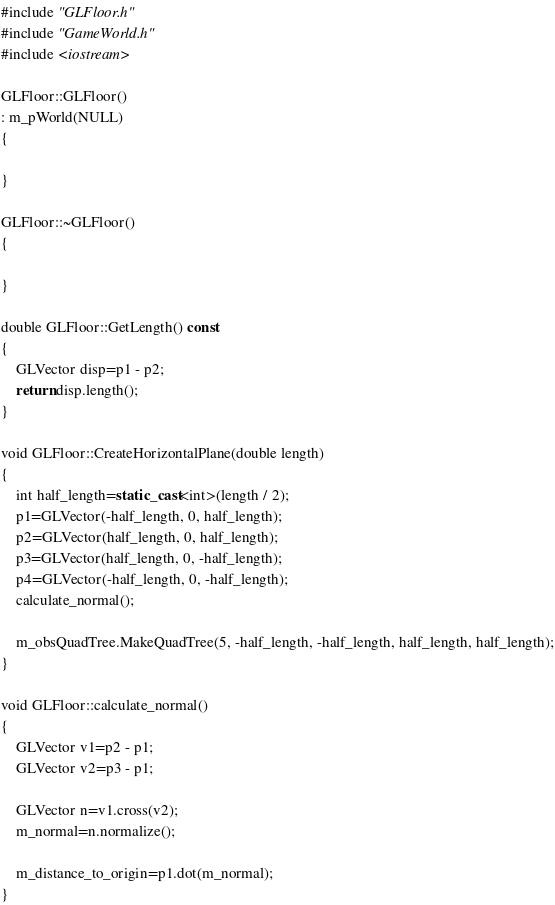Convert code to text. <code><loc_0><loc_0><loc_500><loc_500><_C++_>#include "GLFloor.h"
#include "GameWorld.h"
#include <iostream>

GLFloor::GLFloor()
: m_pWorld(NULL)
{
	
}

GLFloor::~GLFloor()
{
	
}

double GLFloor::GetLength() const
{
	GLVector disp=p1 - p2;
	return disp.length();
}

void GLFloor::CreateHorizontalPlane(double length)
{
	int half_length=static_cast<int>(length / 2);
	p1=GLVector(-half_length, 0, half_length);
	p2=GLVector(half_length, 0, half_length);
	p3=GLVector(half_length, 0, -half_length);
	p4=GLVector(-half_length, 0, -half_length);
	calculate_normal();

	m_obsQuadTree.MakeQuadTree(5, -half_length, -half_length, half_length, half_length);
}

void GLFloor::calculate_normal()
{
	GLVector v1=p2 - p1;
	GLVector v2=p3 - p1;

	GLVector n=v1.cross(v2);
	m_normal=n.normalize();

	m_distance_to_origin=p1.dot(m_normal);
}
</code> 